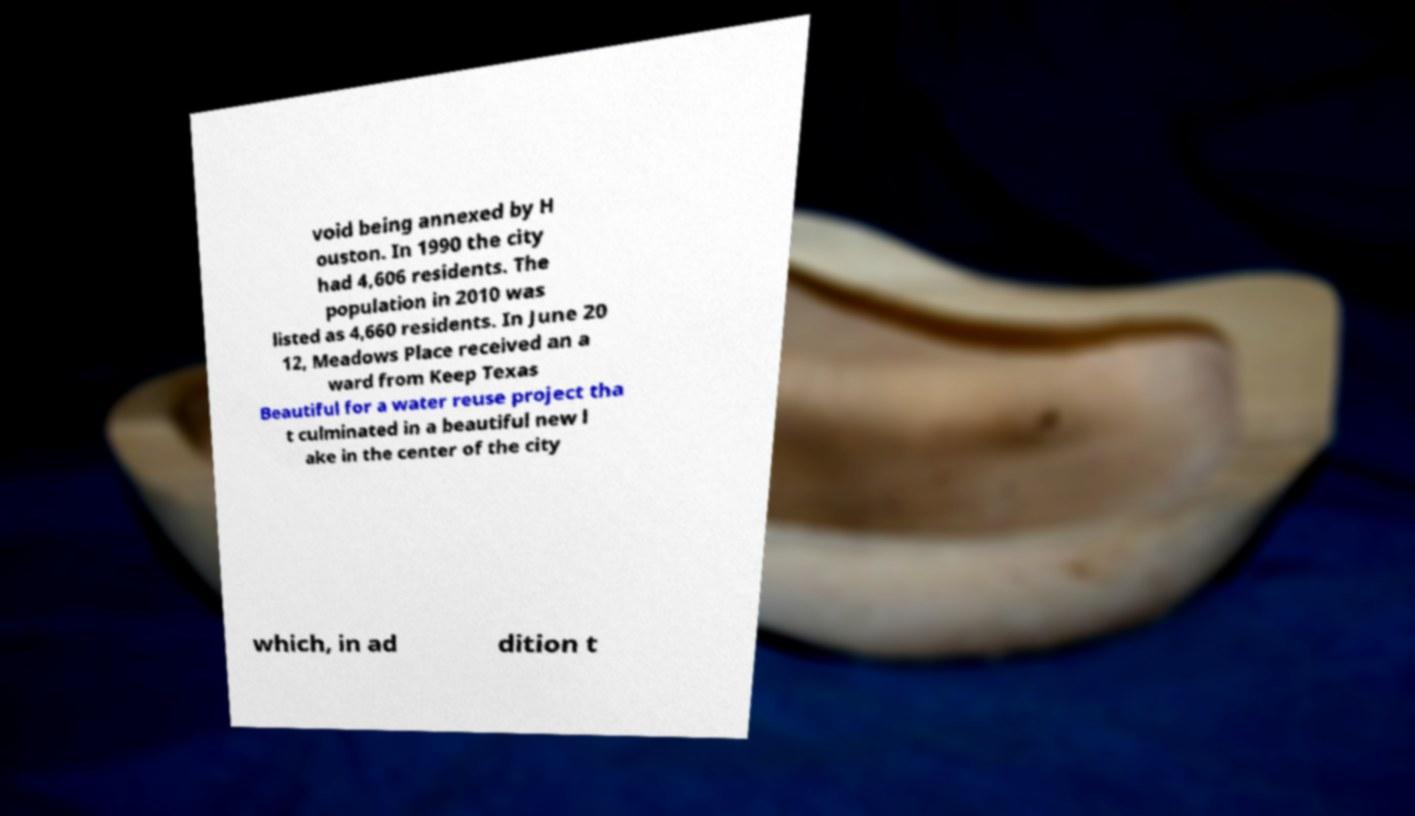Could you assist in decoding the text presented in this image and type it out clearly? void being annexed by H ouston. In 1990 the city had 4,606 residents. The population in 2010 was listed as 4,660 residents. In June 20 12, Meadows Place received an a ward from Keep Texas Beautiful for a water reuse project tha t culminated in a beautiful new l ake in the center of the city which, in ad dition t 